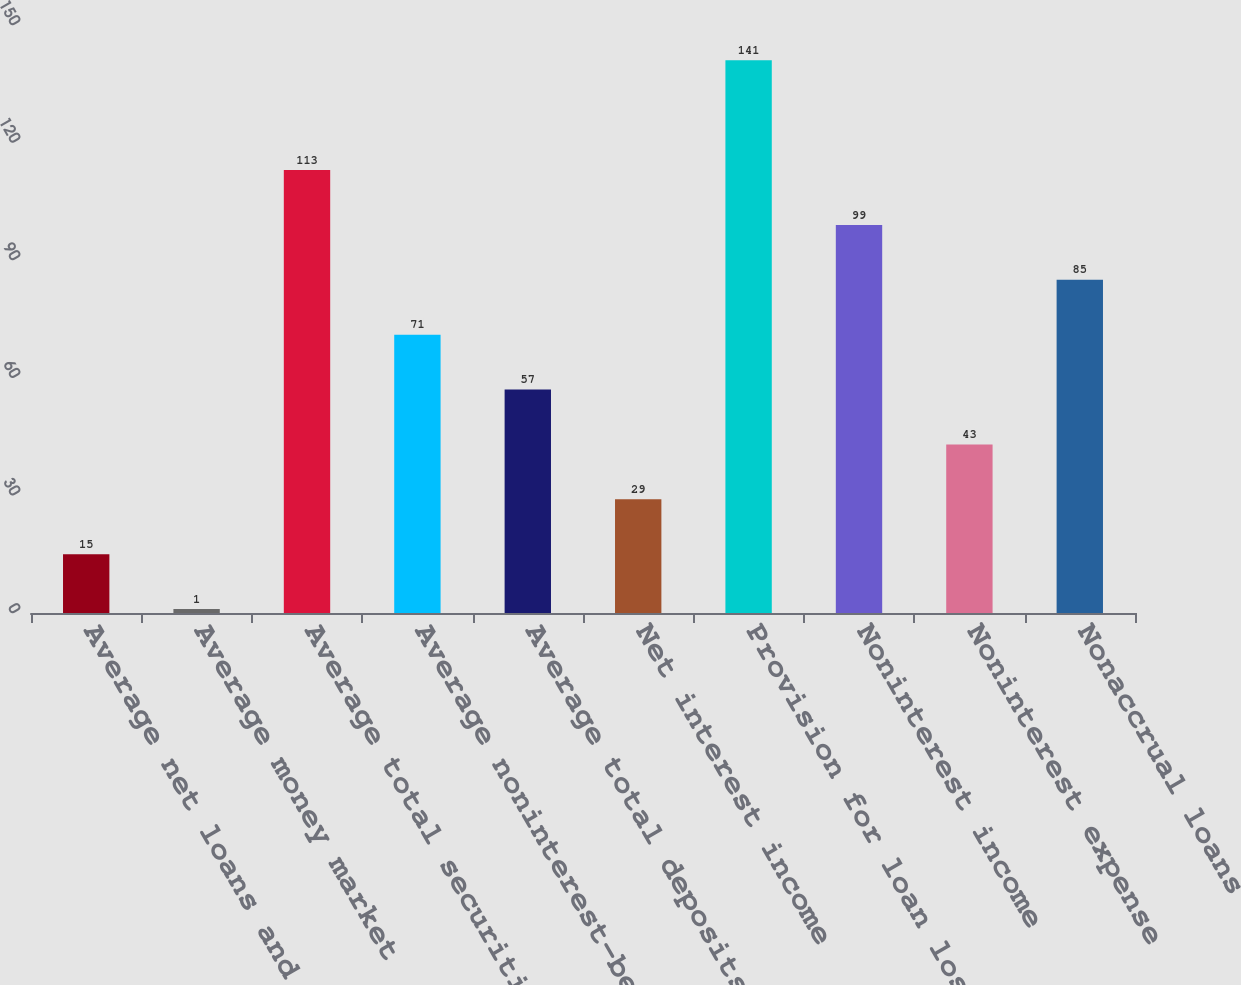Convert chart to OTSL. <chart><loc_0><loc_0><loc_500><loc_500><bar_chart><fcel>Average net loans and leases<fcel>Average money market<fcel>Average total securities<fcel>Average noninterest-bearing<fcel>Average total deposits<fcel>Net interest income<fcel>Provision for loan losses<fcel>Noninterest income<fcel>Noninterest expense<fcel>Nonaccrual loans<nl><fcel>15<fcel>1<fcel>113<fcel>71<fcel>57<fcel>29<fcel>141<fcel>99<fcel>43<fcel>85<nl></chart> 